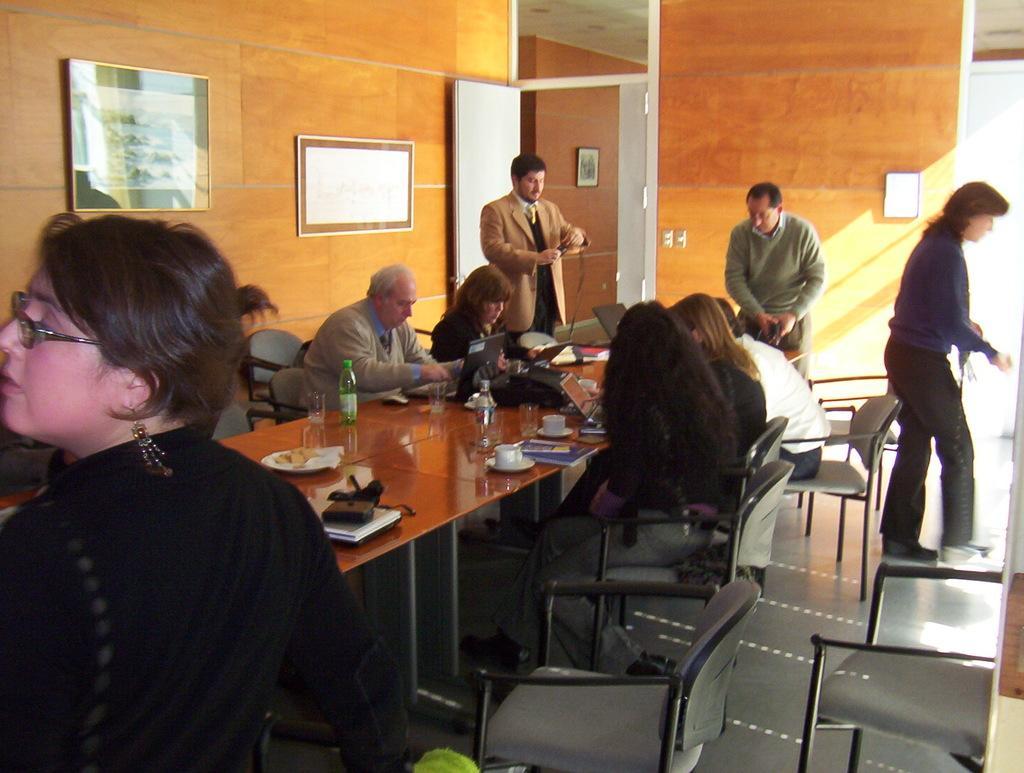Could you give a brief overview of what you see in this image? In the image we can see there are people who are sitting on chair and few people are standing and on the table there are laptops. 